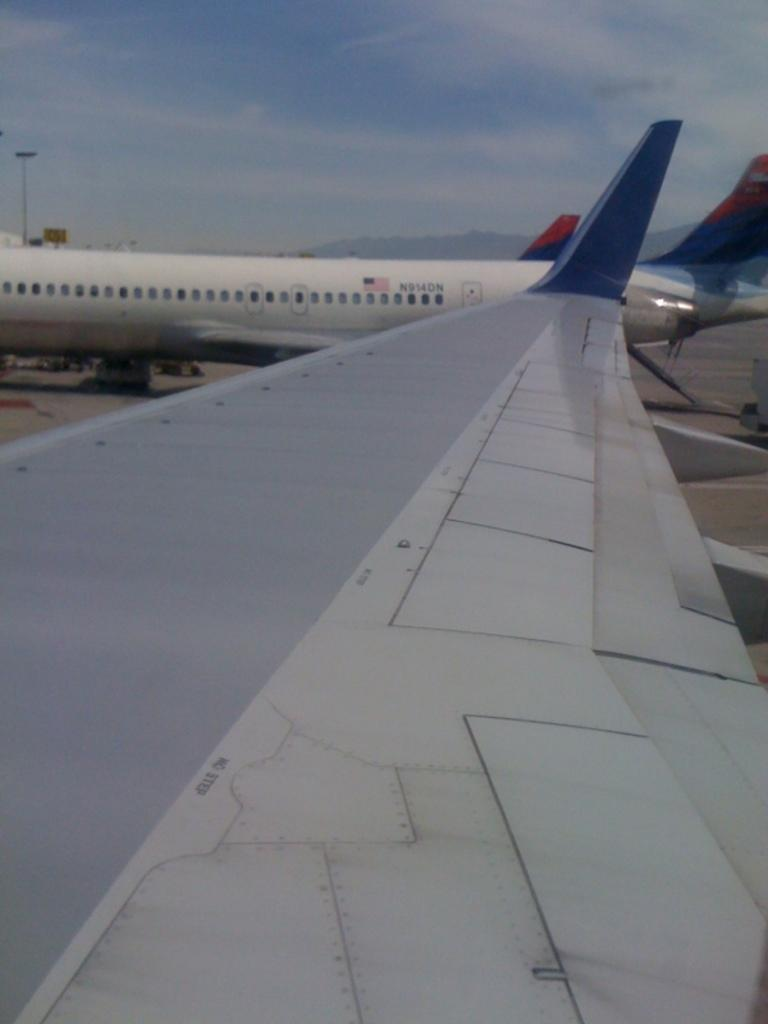What is unusual about the scene in the image? There are aeroplanes on the road in the image. What can be seen above the scene in the image? The sky is visible in the image. What is the condition of the sky in the image? There are clouds in the sky in the image. What advice is the church giving to the planes in the image? There is no church present in the image, and therefore no advice can be given. 